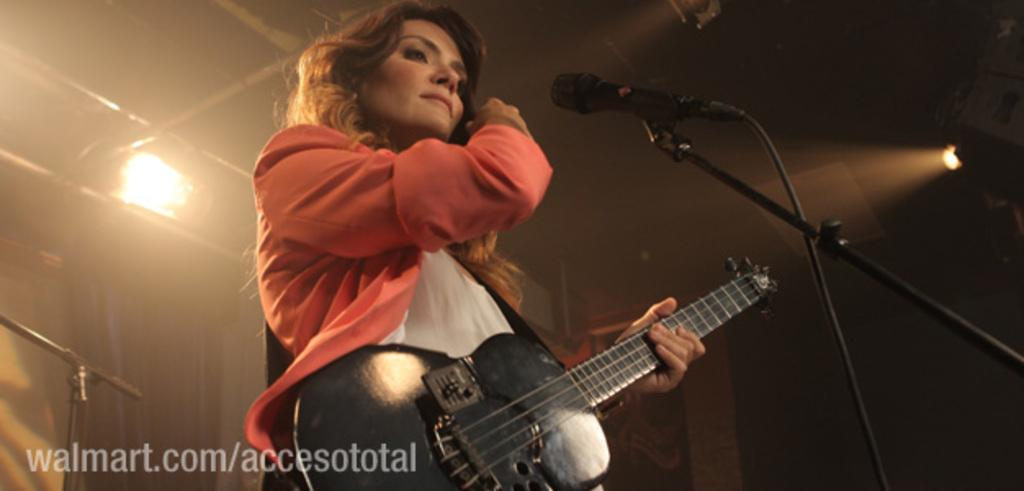Who is the main subject in the image? There is a woman in the image. What is the woman doing in the image? The woman is standing and holding a guitar. What other objects can be seen in the image? There is a microphone in the image. What can be seen in the background of the image? There is a light in the background of the image. Where is the throne located in the image? There is no throne present in the image. Can you tell me the relationship between the woman and the man in the image? There is no man present in the image, so it's not possible to determine any relationship. 